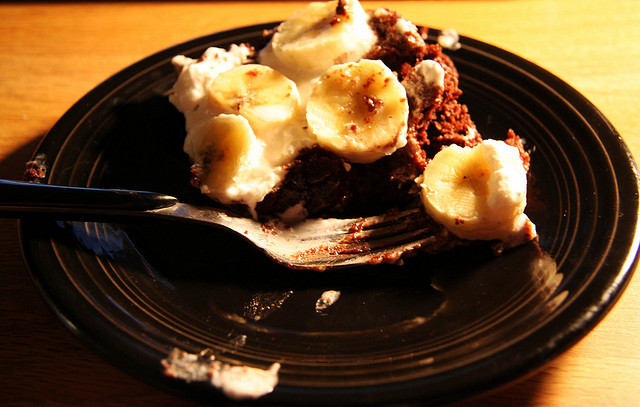How many bananas are there? The image shows a slice of chocolate cake topped with three slices of banana. The warm lighting gives the dessert an appetizing glow. 